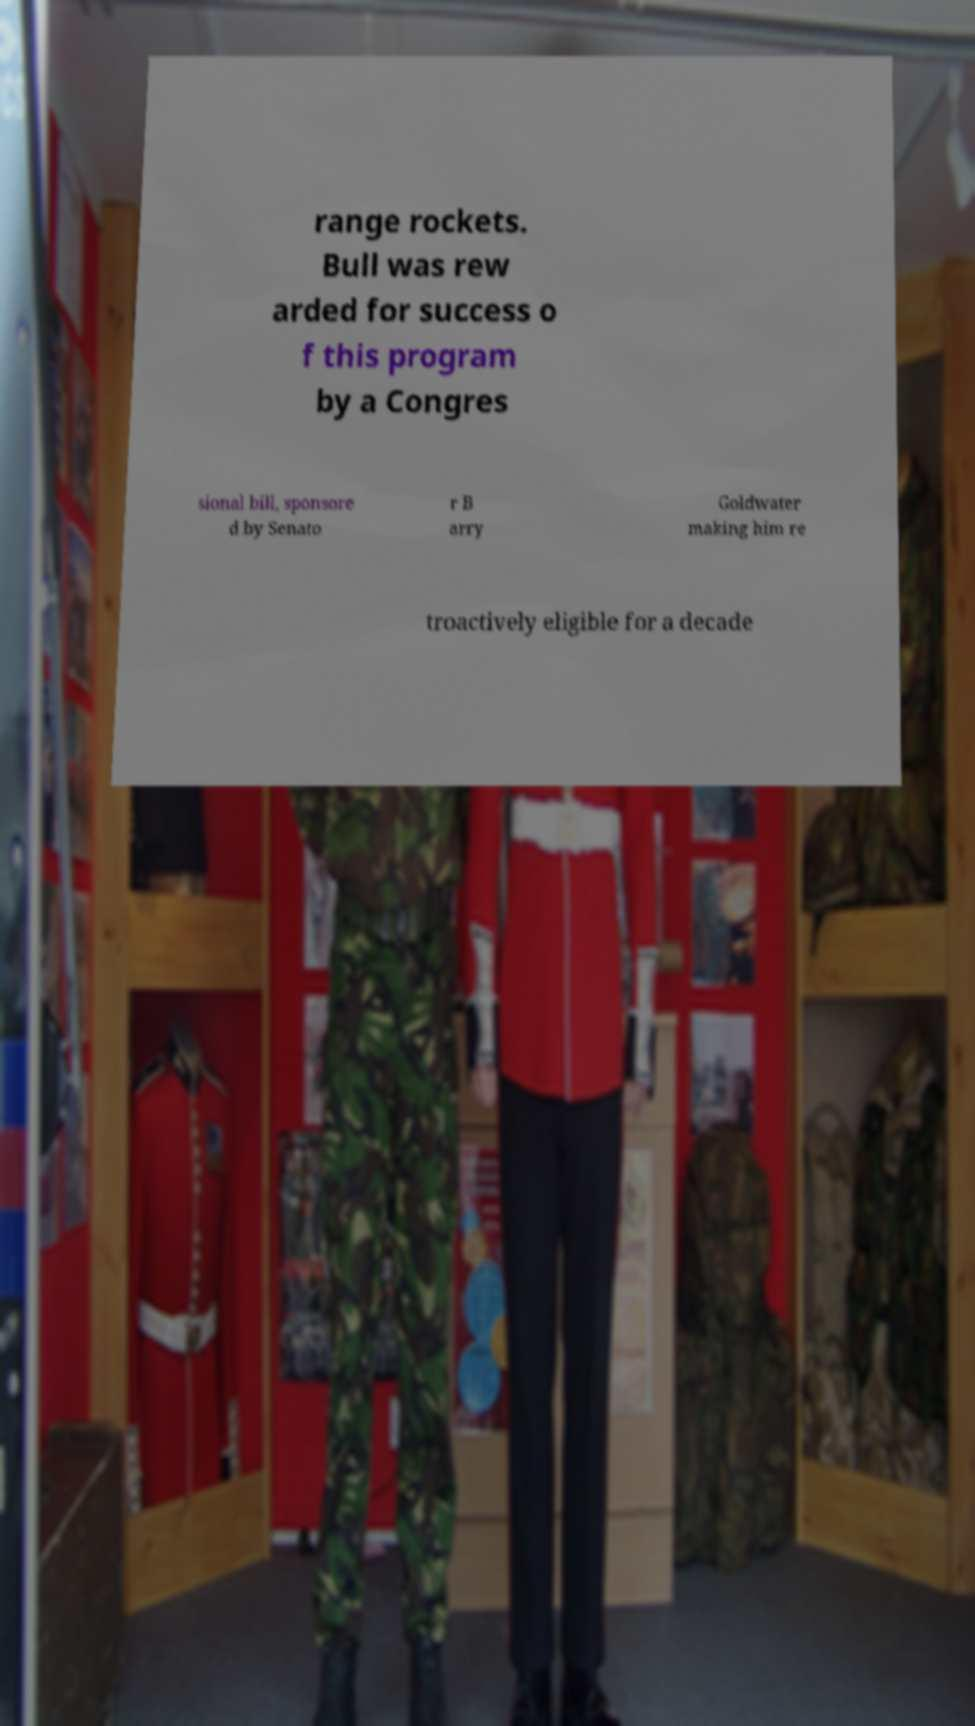Can you accurately transcribe the text from the provided image for me? range rockets. Bull was rew arded for success o f this program by a Congres sional bill, sponsore d by Senato r B arry Goldwater making him re troactively eligible for a decade 